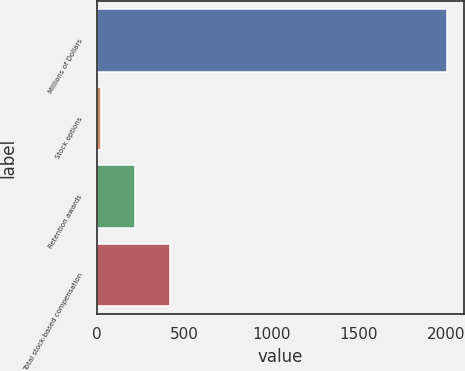Convert chart to OTSL. <chart><loc_0><loc_0><loc_500><loc_500><bar_chart><fcel>Millions of Dollars<fcel>Stock options<fcel>Retention awards<fcel>Total stock-based compensation<nl><fcel>2007<fcel>21<fcel>219.6<fcel>418.2<nl></chart> 